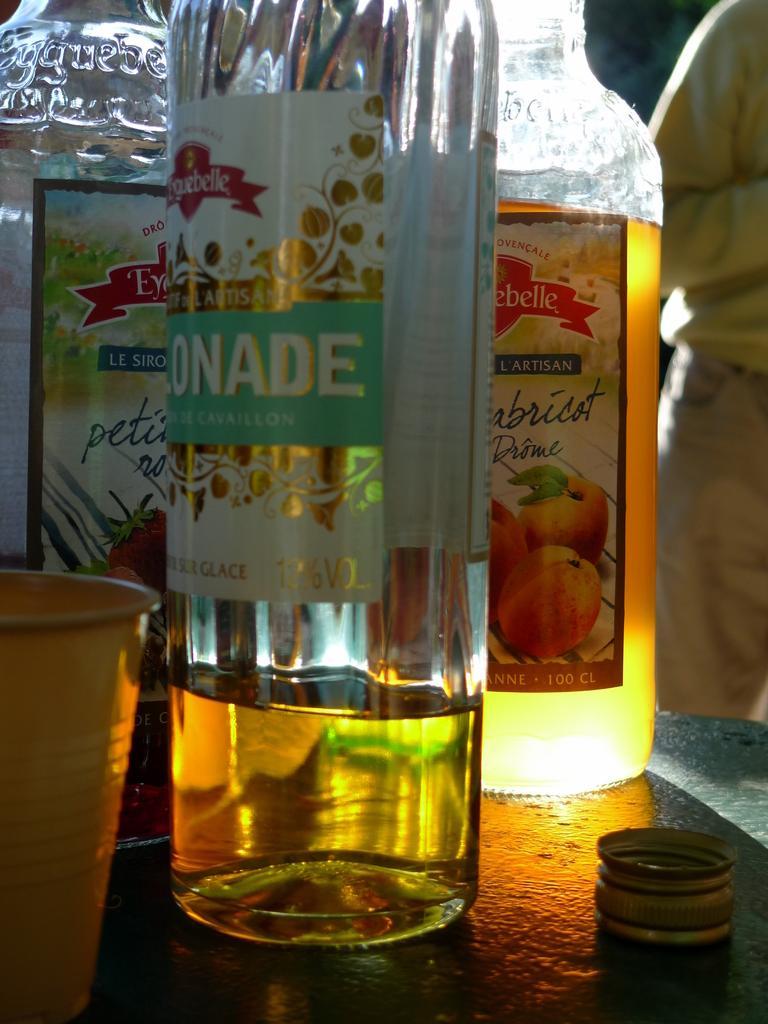In one or two sentences, can you explain what this image depicts? In the image there are three bottles on which it is labelled as 'LISTEN' and we can also see a glass and a cap on right side there is a man standing. 